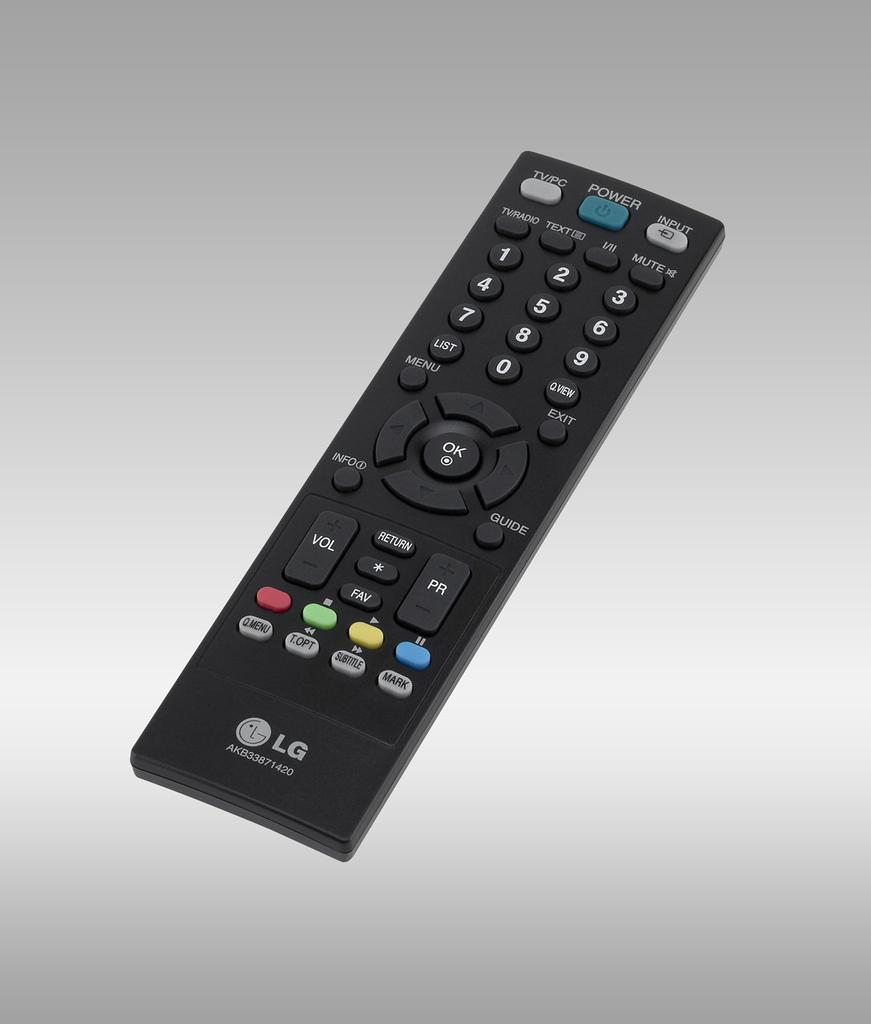<image>
Provide a brief description of the given image. Black LG remote laying flat that works for a LG television 